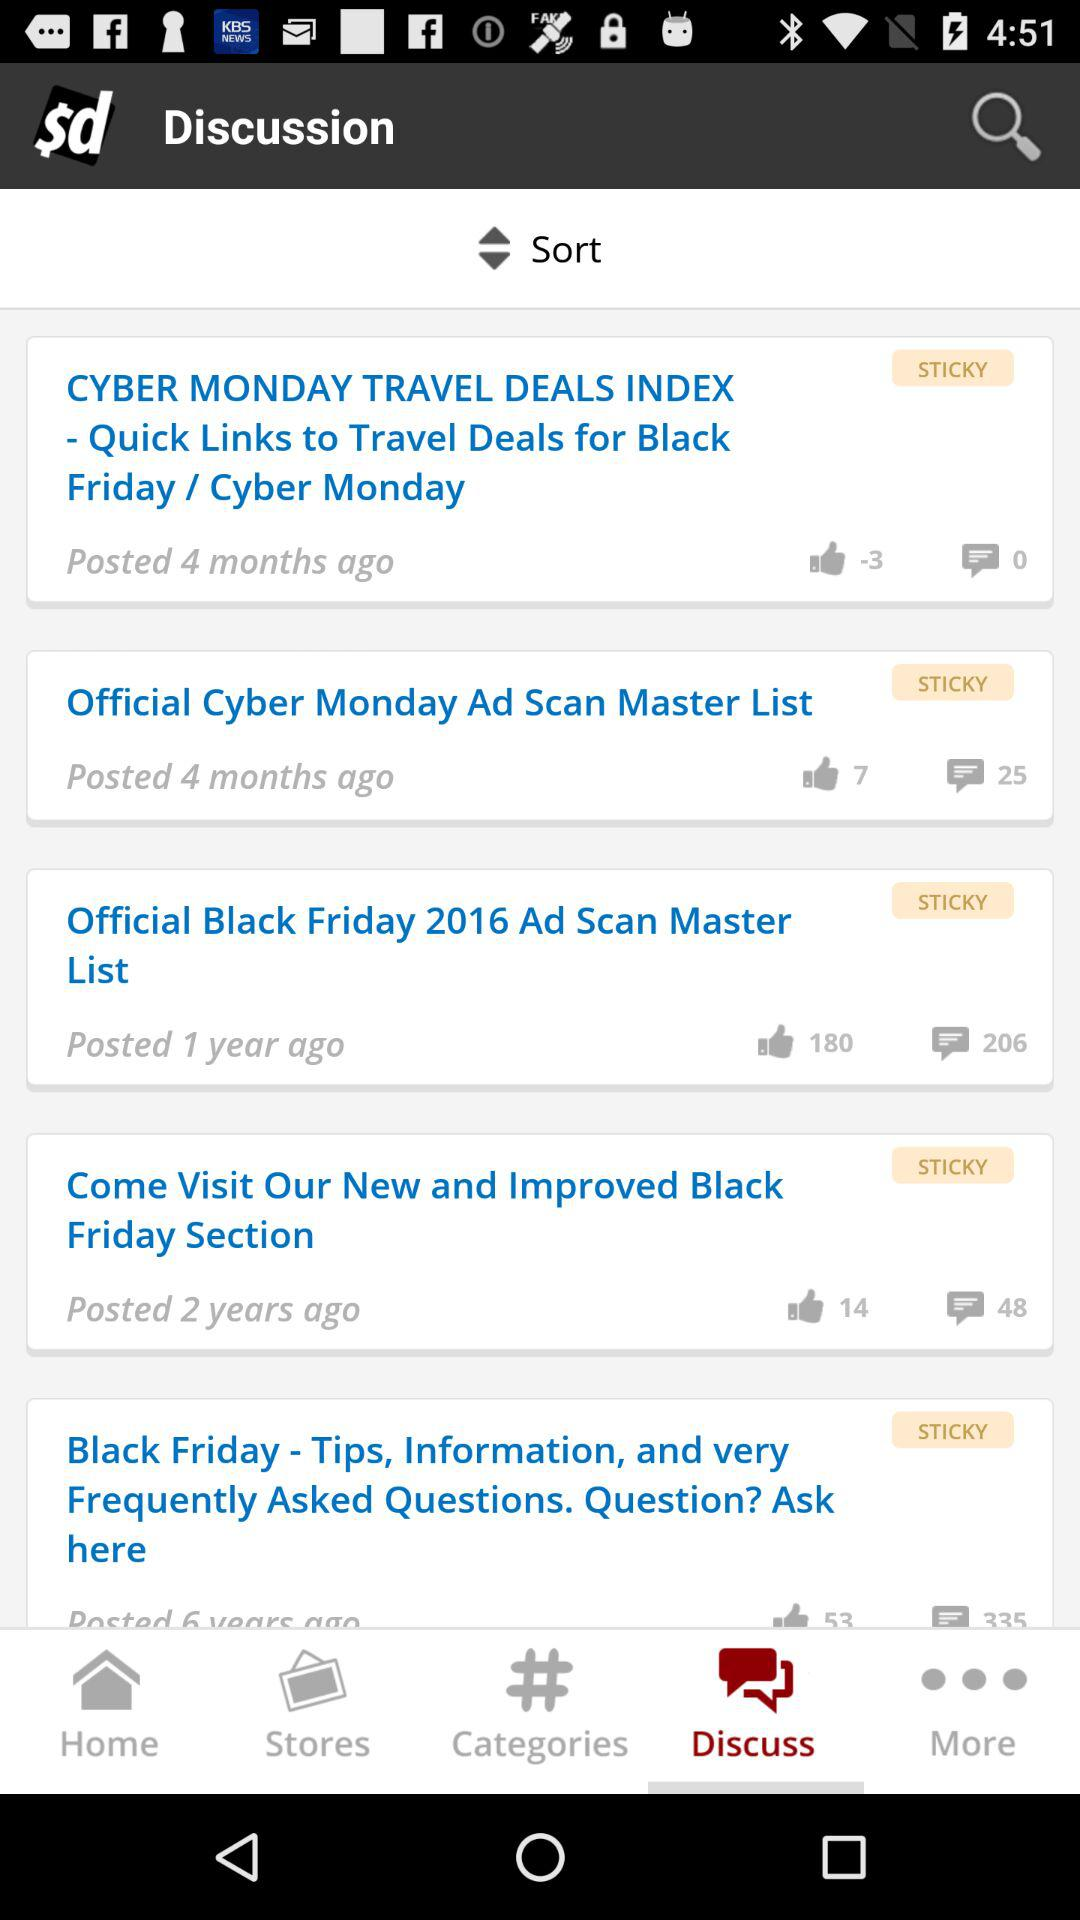How many comments are shown of the "official Black Friday 2016 Ad Scan Master List"? There are 206 comments shown of the "official Black Friday 2016 Ad Scan Master List". 